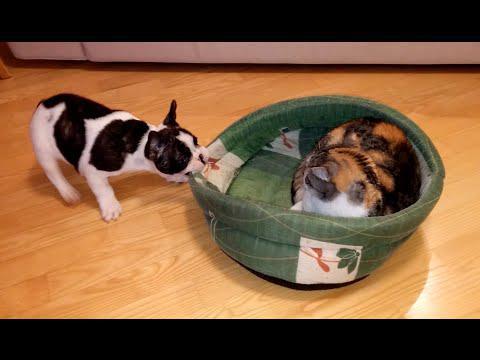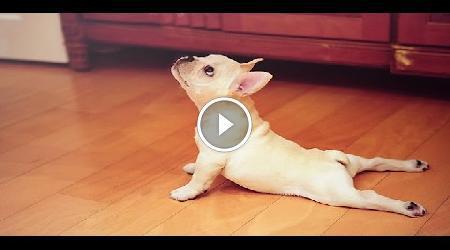The first image is the image on the left, the second image is the image on the right. Examine the images to the left and right. Is the description "There are puppies in each image." accurate? Answer yes or no. Yes. The first image is the image on the left, the second image is the image on the right. Given the left and right images, does the statement "A black-and-white faced dog is leaning back on its haunches and at least appears to face another animal." hold true? Answer yes or no. Yes. 